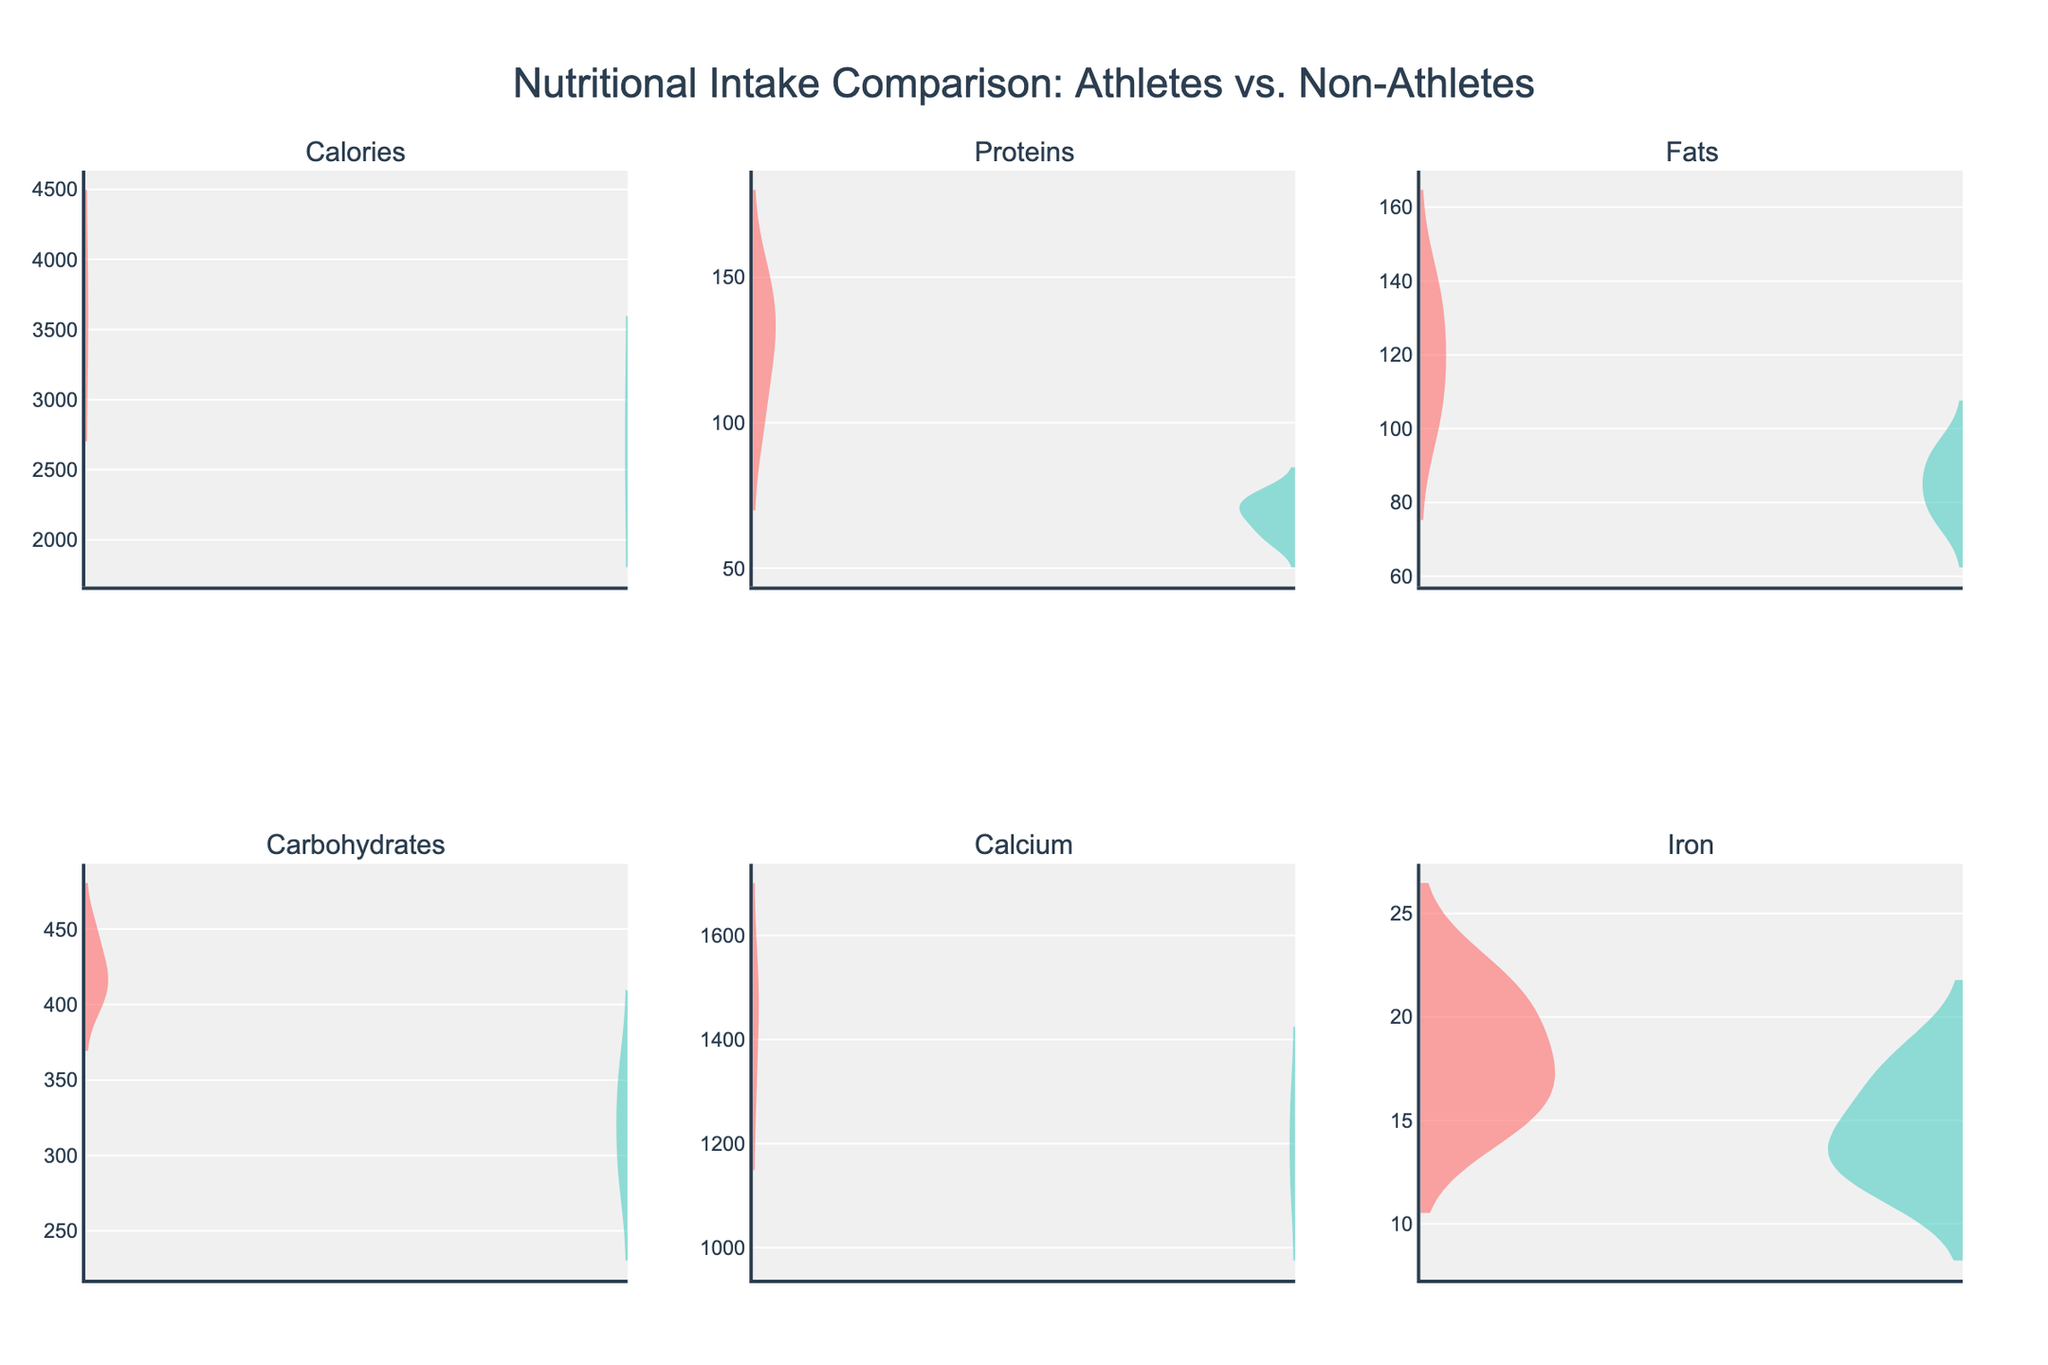What is the title of the figure? The title is located at the top of the figure and is meant to provide a summary of the figure’s content.
Answer: Nutritional Intake Comparison: Athletes vs. Non-Athletes Which group consumes more calories on average? To find this, look at the calories subplot and compare the data ranges and densities for both groups. The "Athlete" group generally has higher density values at higher calorie intakes.
Answer: Athletes How does the iron intake compare between athletes and non-athletes? Check the subplot for iron intake. The distribution densities for athletes show higher values compared to non-athletes, indicating that athletes consume more iron.
Answer: Athletes consume more iron Which subplot shows the smallest difference between athletes and non-athletes? By examining all subplots, the proteins subplot indicates the smallest difference with overlapping densities closer to each other than in other nutrients.
Answer: Proteins Do athletes have a higher intake of carbohydrates compared to non-athletes? Look at the carbohydrates subplot. The density values for athletes are notably higher than those for non-athletes, revealing a higher intake of carbohydrates among athletes.
Answer: Yes What is the typical range of calcium intake for non-athletes? Refer to the calcium subplot and look for the density span of the non-athletes, which appears primarily between 1100 and 1300.
Answer: 1100 to 1300 Is there any nutrient where non-athletes consume more than athletes? By reviewing all subplots, none show non-athletes consuming more of any nutrient than athletes; athletes consistently consume more.
Answer: No How does the density plot indicate the distribution of fats for non-athletes? The fats subplot shows that non-athletes have a slightly lower and more compressed range of density at a lower intake value compared to athletes.
Answer: Lower and compressed range Which nutrient for athletes shows the most significant increase in intake compared to non-athletes? Check each subplot for differences; the calories and iron subplots show the greatest separation between athletes and non-athletes.
Answer: Calories and Iron What visual elements distinguish between athletes and non-athletes on the figure? Athletes are colored differently from non-athletes (athletes in a reddish hue, non-athletes in a greenish hue) and the plot density follows positive and negative symmetries.
Answer: Color and symmetry 